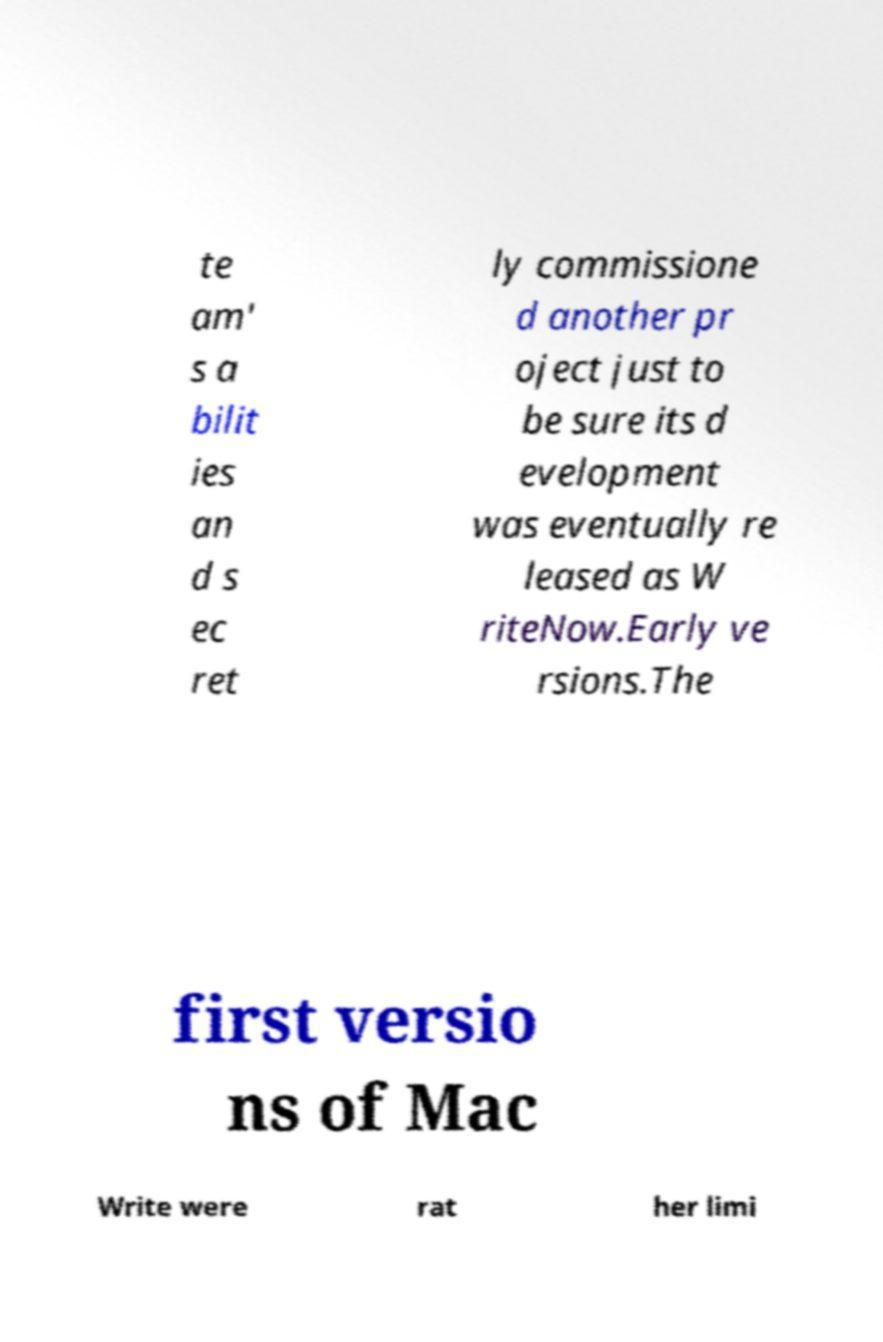For documentation purposes, I need the text within this image transcribed. Could you provide that? te am' s a bilit ies an d s ec ret ly commissione d another pr oject just to be sure its d evelopment was eventually re leased as W riteNow.Early ve rsions.The first versio ns of Mac Write were rat her limi 